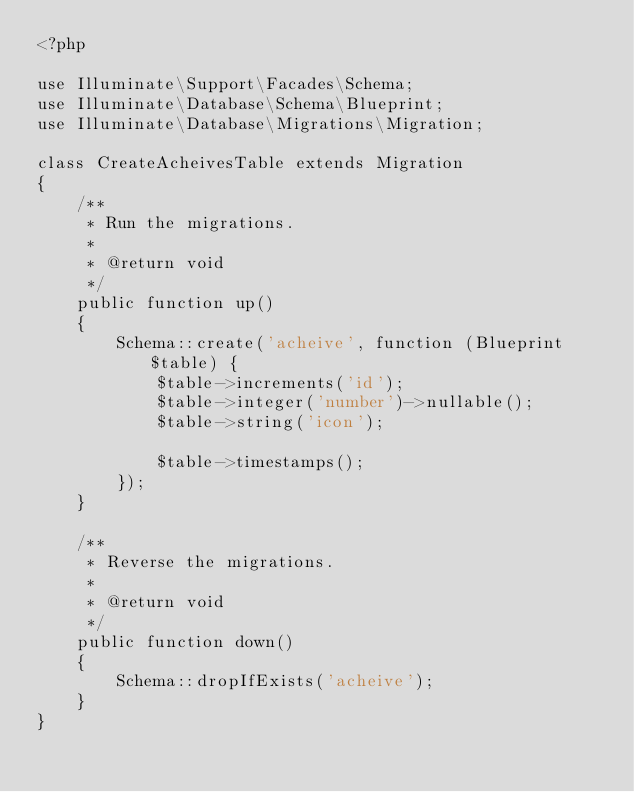Convert code to text. <code><loc_0><loc_0><loc_500><loc_500><_PHP_><?php

use Illuminate\Support\Facades\Schema;
use Illuminate\Database\Schema\Blueprint;
use Illuminate\Database\Migrations\Migration;

class CreateAcheivesTable extends Migration
{
    /**
     * Run the migrations.
     *
     * @return void
     */
    public function up()
    {
        Schema::create('acheive', function (Blueprint $table) {
            $table->increments('id');
            $table->integer('number')->nullable();
            $table->string('icon');

            $table->timestamps();
        });
    }

    /**
     * Reverse the migrations.
     *
     * @return void
     */
    public function down()
    {
        Schema::dropIfExists('acheive');
    }
}
</code> 